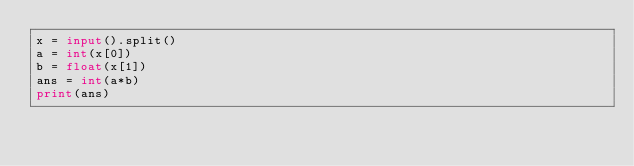<code> <loc_0><loc_0><loc_500><loc_500><_Python_>x = input().split()
a = int(x[0])
b = float(x[1])
ans = int(a*b)
print(ans)</code> 